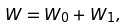<formula> <loc_0><loc_0><loc_500><loc_500>W = W _ { 0 } + W _ { 1 } ,</formula> 